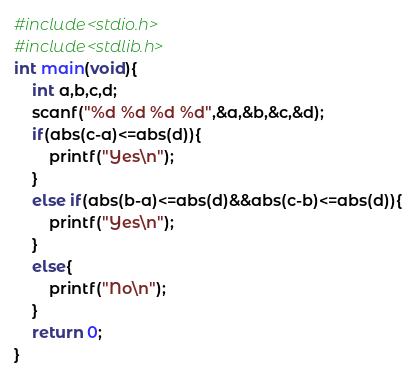<code> <loc_0><loc_0><loc_500><loc_500><_C_>#include<stdio.h>
#include<stdlib.h>
int main(void){
    int a,b,c,d;
    scanf("%d %d %d %d",&a,&b,&c,&d);
    if(abs(c-a)<=abs(d)){
        printf("Yes\n");
    }
    else if(abs(b-a)<=abs(d)&&abs(c-b)<=abs(d)){
        printf("Yes\n");
    }
    else{
        printf("No\n");
    }
    return 0;
}
</code> 